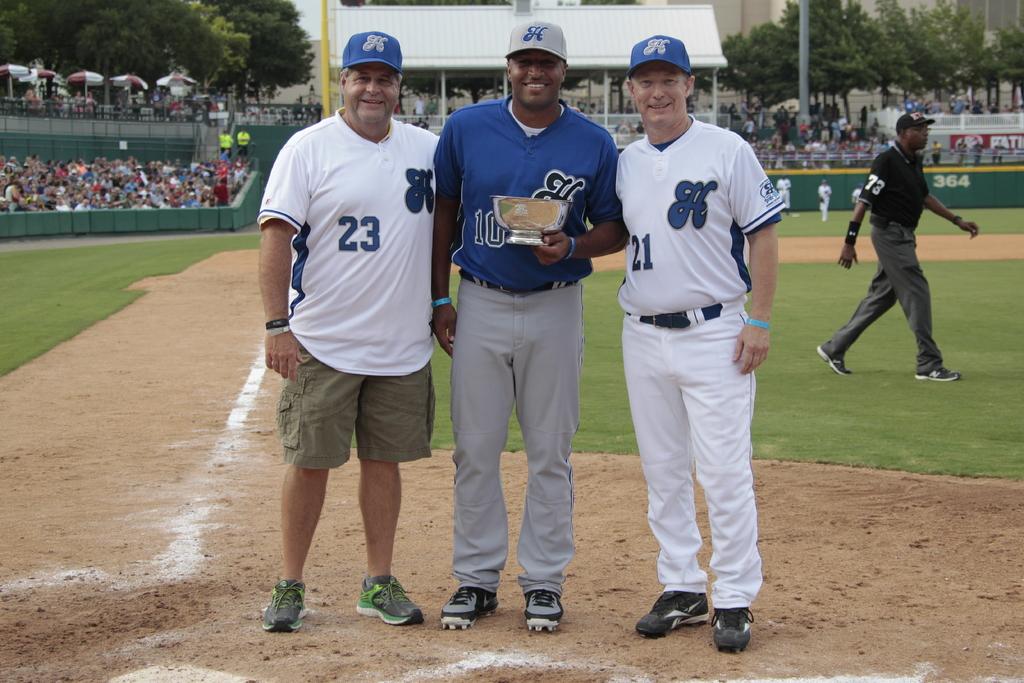What number is on the white jersey to the left?
Keep it short and to the point. 23. 